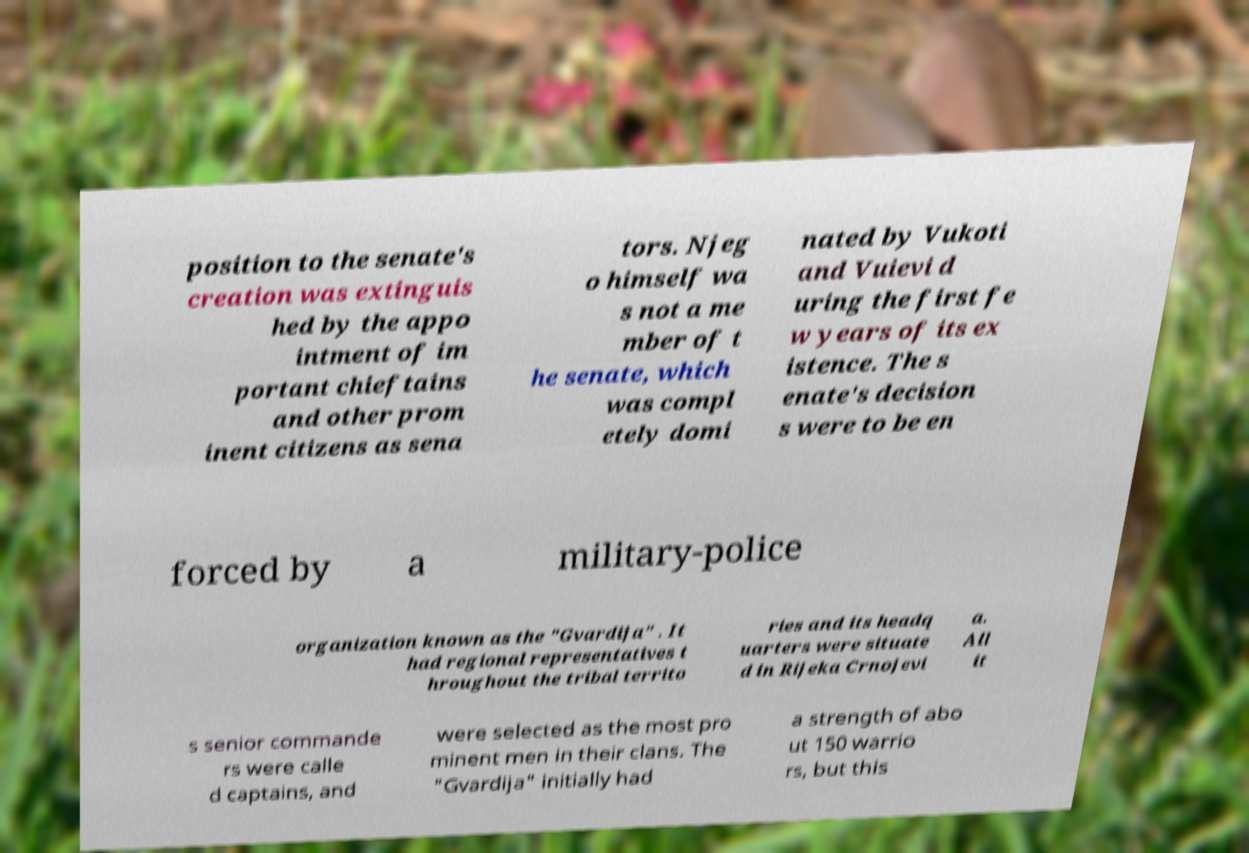Can you accurately transcribe the text from the provided image for me? position to the senate's creation was extinguis hed by the appo intment of im portant chieftains and other prom inent citizens as sena tors. Njeg o himself wa s not a me mber of t he senate, which was compl etely domi nated by Vukoti and Vuievi d uring the first fe w years of its ex istence. The s enate's decision s were to be en forced by a military-police organization known as the "Gvardija" . It had regional representatives t hroughout the tribal territo ries and its headq uarters were situate d in Rijeka Crnojevi a. All it s senior commande rs were calle d captains, and were selected as the most pro minent men in their clans. The "Gvardija" initially had a strength of abo ut 150 warrio rs, but this 